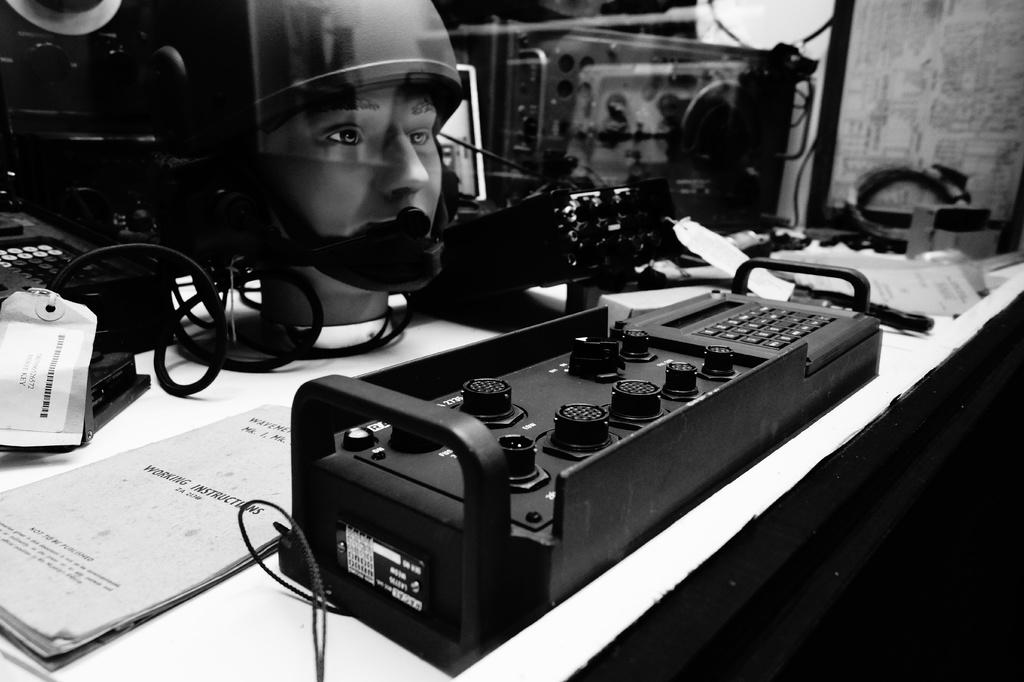What is one of the objects on the table in the image? There is a file on the table in the image. What type of electronic device is in the image? There is an electronic device in the image. What part of a mannequin can be seen in the image? The head of a mannequin is present in the image. What connects the objects on the table in the image? There are cables in the image. What type of curve can be seen on the wall in the image? There is no wall present in the image, so it is not possible to determine if there is a curve or not. Are there any ants visible on the table in the image? There are no ants present in the image. 